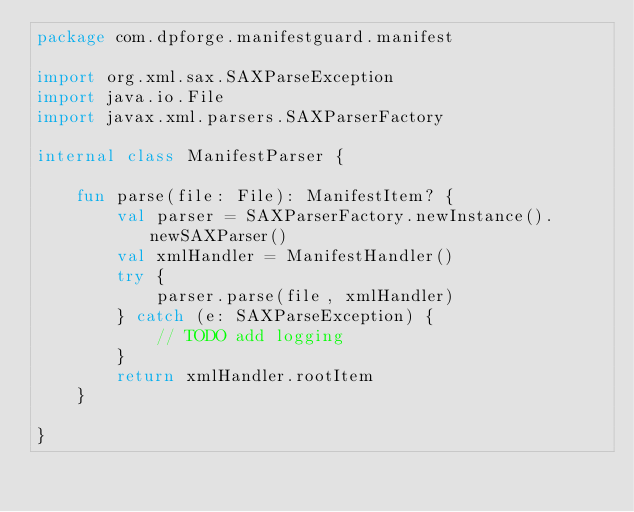<code> <loc_0><loc_0><loc_500><loc_500><_Kotlin_>package com.dpforge.manifestguard.manifest

import org.xml.sax.SAXParseException
import java.io.File
import javax.xml.parsers.SAXParserFactory

internal class ManifestParser {

    fun parse(file: File): ManifestItem? {
        val parser = SAXParserFactory.newInstance().newSAXParser()
        val xmlHandler = ManifestHandler()
        try {
            parser.parse(file, xmlHandler)
        } catch (e: SAXParseException) {
            // TODO add logging
        }
        return xmlHandler.rootItem
    }

}</code> 